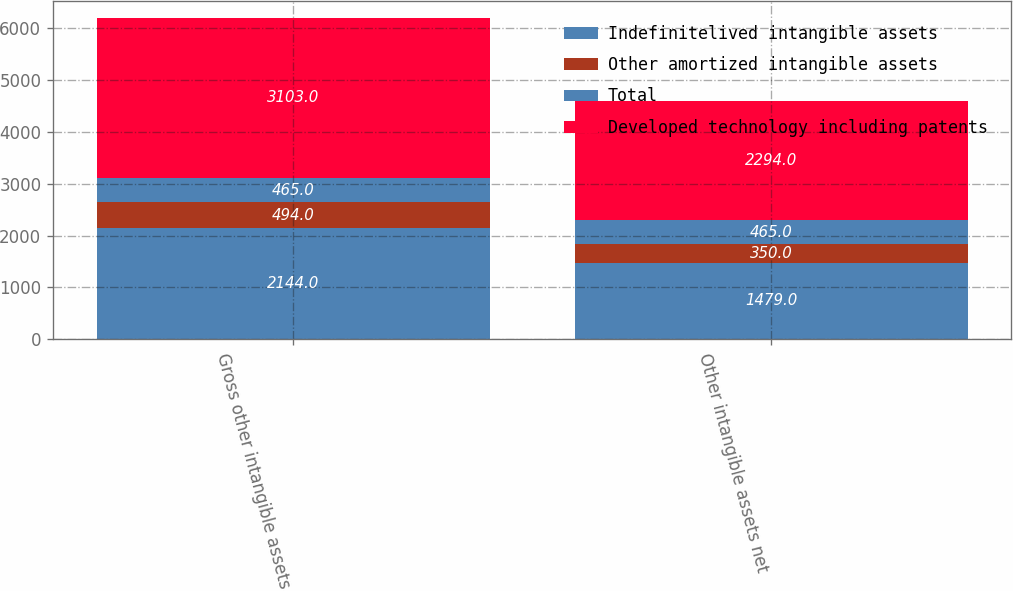<chart> <loc_0><loc_0><loc_500><loc_500><stacked_bar_chart><ecel><fcel>Gross other intangible assets<fcel>Other intangible assets net<nl><fcel>Indefinitelived intangible assets<fcel>2144<fcel>1479<nl><fcel>Other amortized intangible assets<fcel>494<fcel>350<nl><fcel>Total<fcel>465<fcel>465<nl><fcel>Developed technology including patents<fcel>3103<fcel>2294<nl></chart> 